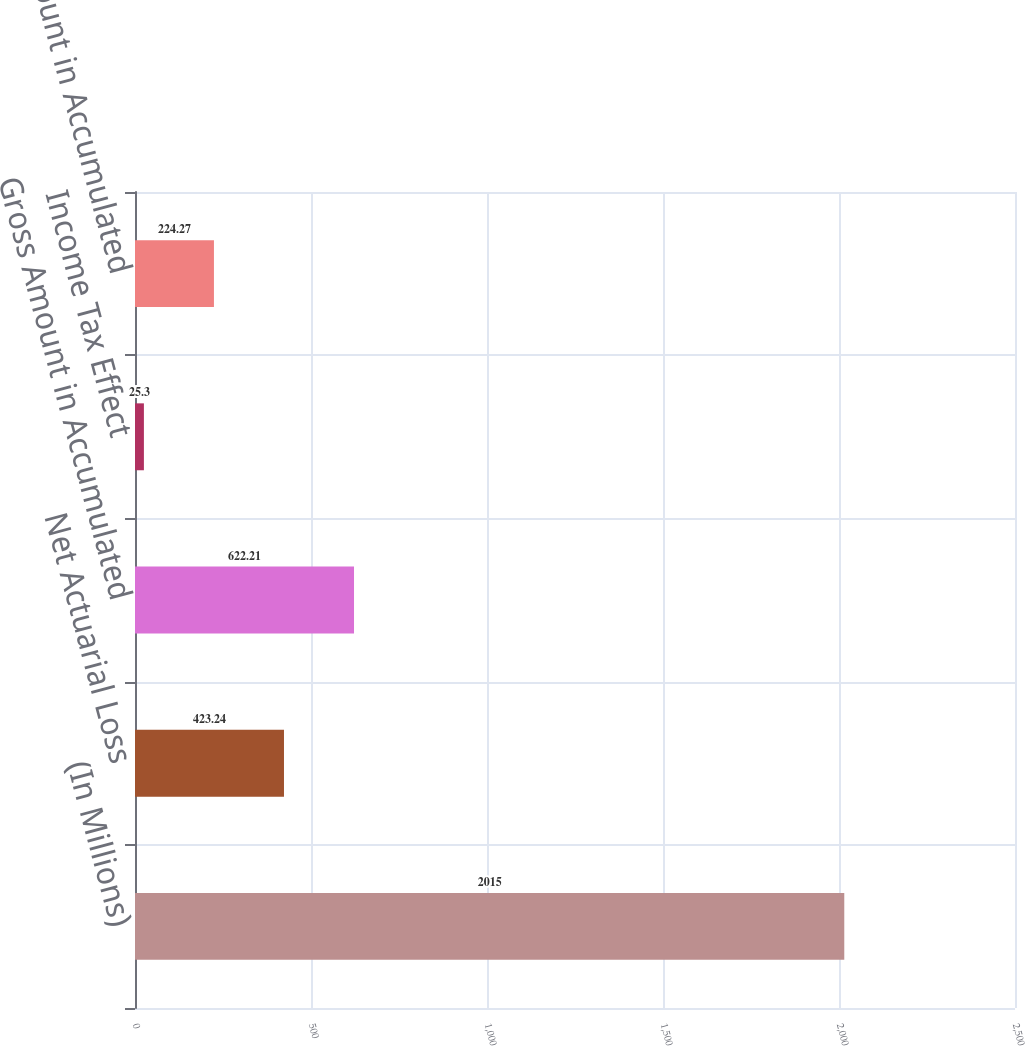<chart> <loc_0><loc_0><loc_500><loc_500><bar_chart><fcel>(In Millions)<fcel>Net Actuarial Loss<fcel>Gross Amount in Accumulated<fcel>Income Tax Effect<fcel>Net Amount in Accumulated<nl><fcel>2015<fcel>423.24<fcel>622.21<fcel>25.3<fcel>224.27<nl></chart> 